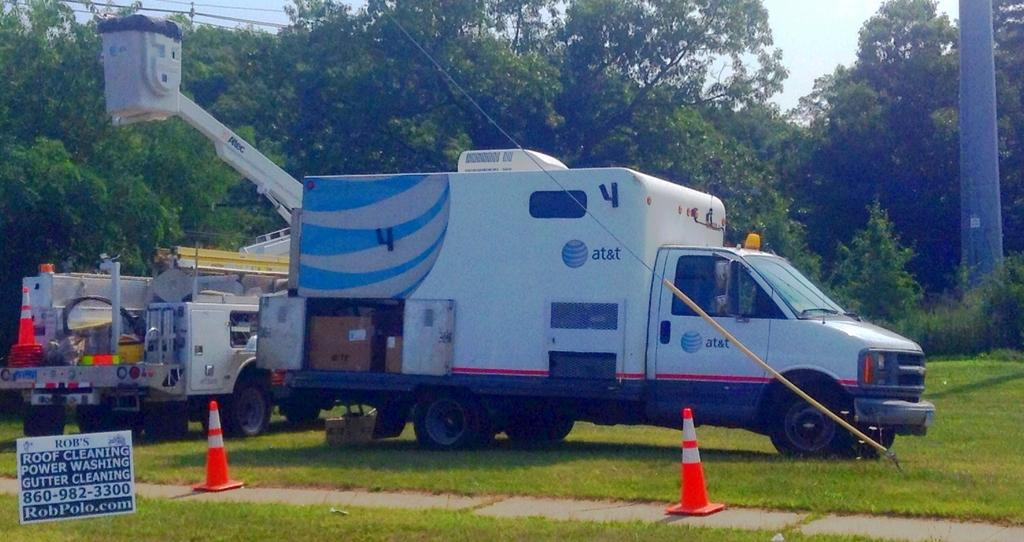<image>
Offer a succinct explanation of the picture presented. a large with van with cherry picker in the background, can has at&t on it 